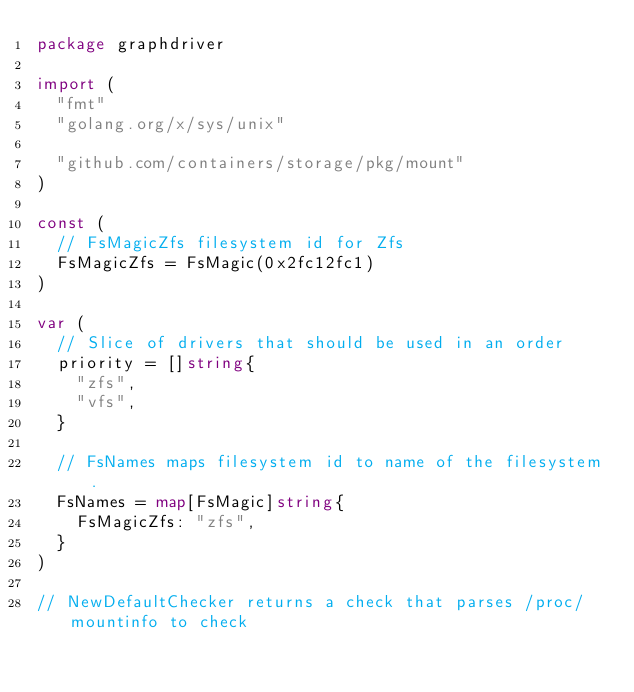<code> <loc_0><loc_0><loc_500><loc_500><_Go_>package graphdriver

import (
	"fmt"
	"golang.org/x/sys/unix"

	"github.com/containers/storage/pkg/mount"
)

const (
	// FsMagicZfs filesystem id for Zfs
	FsMagicZfs = FsMagic(0x2fc12fc1)
)

var (
	// Slice of drivers that should be used in an order
	priority = []string{
		"zfs",
		"vfs",
	}

	// FsNames maps filesystem id to name of the filesystem.
	FsNames = map[FsMagic]string{
		FsMagicZfs: "zfs",
	}
)

// NewDefaultChecker returns a check that parses /proc/mountinfo to check</code> 